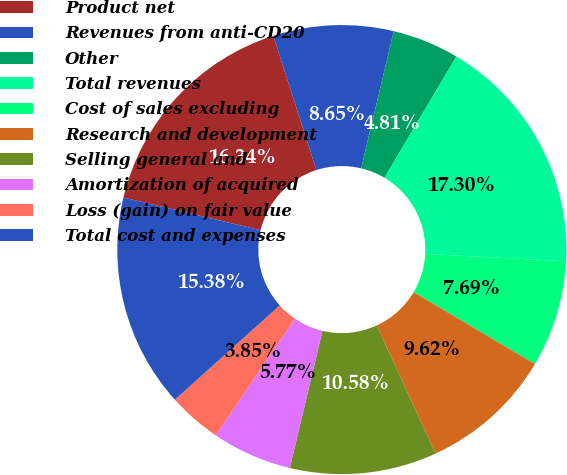Convert chart. <chart><loc_0><loc_0><loc_500><loc_500><pie_chart><fcel>Product net<fcel>Revenues from anti-CD20<fcel>Other<fcel>Total revenues<fcel>Cost of sales excluding<fcel>Research and development<fcel>Selling general and<fcel>Amortization of acquired<fcel>Loss (gain) on fair value<fcel>Total cost and expenses<nl><fcel>16.34%<fcel>8.65%<fcel>4.81%<fcel>17.3%<fcel>7.69%<fcel>9.62%<fcel>10.58%<fcel>5.77%<fcel>3.85%<fcel>15.38%<nl></chart> 